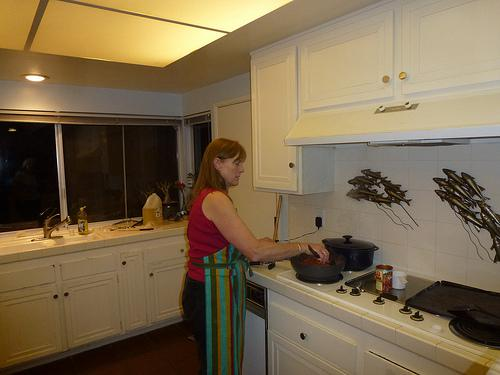Question: what room in the house is this?
Choices:
A. Bedroom.
B. Living room.
C. Kitchen.
D. Bathroom.
Answer with the letter. Answer: C Question: what color are the pots she is cooking with?
Choices:
A. Black.
B. Silver.
C. Red.
D. Brown.
Answer with the letter. Answer: A 